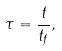Convert formula to latex. <formula><loc_0><loc_0><loc_500><loc_500>\tau = \frac { t } { t _ { f } } ,</formula> 